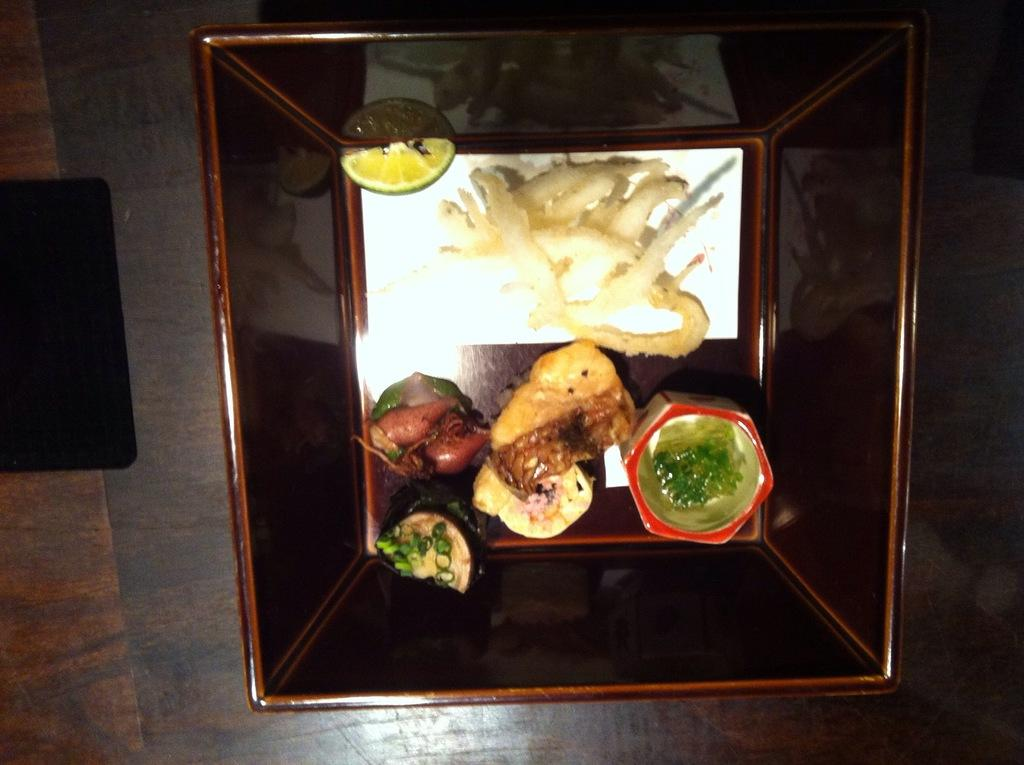What is in the bowl that is visible in the image? There is a bowl with a lemon slice in the image. What other food items are present in the bowl? There are other food items in the bowl. Can you describe the object on the wooden surface on the left side of the image? There is a black object on the wooden surface on the left side of the image. What type of bell can be heard ringing in the image? There is no bell present in the image, and therefore no sound can be heard. 